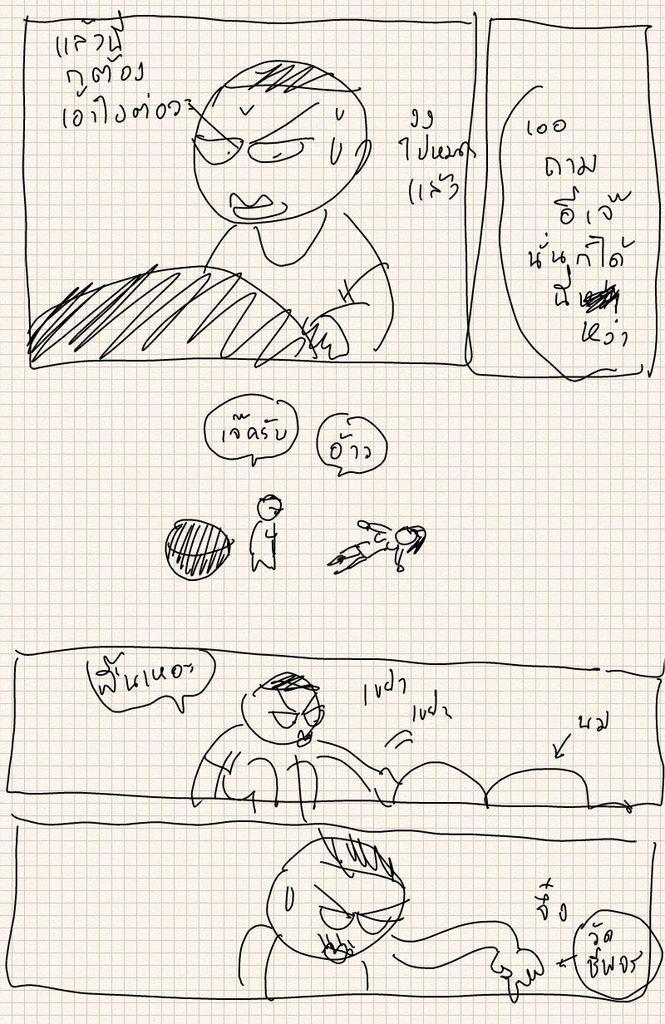Could you give a brief overview of what you see in this image? In this image I can see different types of sketches. I can also see something is written on the top, in the centre and on the bottom side of the image. 